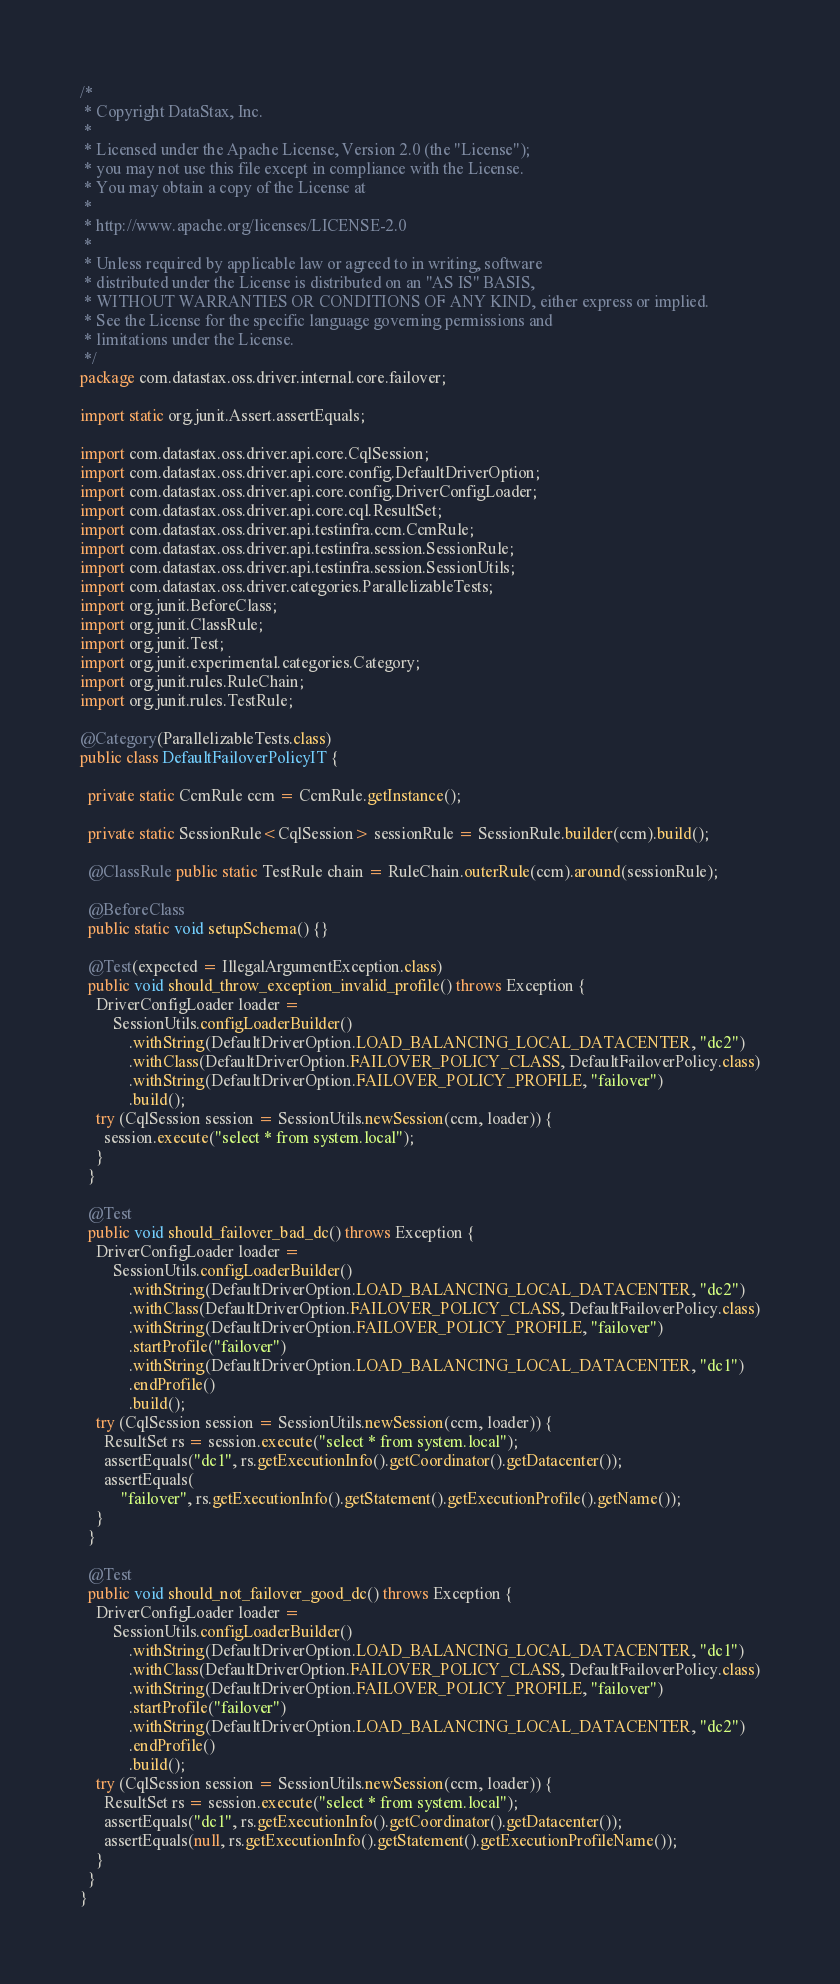Convert code to text. <code><loc_0><loc_0><loc_500><loc_500><_Java_>/*
 * Copyright DataStax, Inc.
 *
 * Licensed under the Apache License, Version 2.0 (the "License");
 * you may not use this file except in compliance with the License.
 * You may obtain a copy of the License at
 *
 * http://www.apache.org/licenses/LICENSE-2.0
 *
 * Unless required by applicable law or agreed to in writing, software
 * distributed under the License is distributed on an "AS IS" BASIS,
 * WITHOUT WARRANTIES OR CONDITIONS OF ANY KIND, either express or implied.
 * See the License for the specific language governing permissions and
 * limitations under the License.
 */
package com.datastax.oss.driver.internal.core.failover;

import static org.junit.Assert.assertEquals;

import com.datastax.oss.driver.api.core.CqlSession;
import com.datastax.oss.driver.api.core.config.DefaultDriverOption;
import com.datastax.oss.driver.api.core.config.DriverConfigLoader;
import com.datastax.oss.driver.api.core.cql.ResultSet;
import com.datastax.oss.driver.api.testinfra.ccm.CcmRule;
import com.datastax.oss.driver.api.testinfra.session.SessionRule;
import com.datastax.oss.driver.api.testinfra.session.SessionUtils;
import com.datastax.oss.driver.categories.ParallelizableTests;
import org.junit.BeforeClass;
import org.junit.ClassRule;
import org.junit.Test;
import org.junit.experimental.categories.Category;
import org.junit.rules.RuleChain;
import org.junit.rules.TestRule;

@Category(ParallelizableTests.class)
public class DefaultFailoverPolicyIT {

  private static CcmRule ccm = CcmRule.getInstance();

  private static SessionRule<CqlSession> sessionRule = SessionRule.builder(ccm).build();

  @ClassRule public static TestRule chain = RuleChain.outerRule(ccm).around(sessionRule);

  @BeforeClass
  public static void setupSchema() {}

  @Test(expected = IllegalArgumentException.class)
  public void should_throw_exception_invalid_profile() throws Exception {
    DriverConfigLoader loader =
        SessionUtils.configLoaderBuilder()
            .withString(DefaultDriverOption.LOAD_BALANCING_LOCAL_DATACENTER, "dc2")
            .withClass(DefaultDriverOption.FAILOVER_POLICY_CLASS, DefaultFailoverPolicy.class)
            .withString(DefaultDriverOption.FAILOVER_POLICY_PROFILE, "failover")
            .build();
    try (CqlSession session = SessionUtils.newSession(ccm, loader)) {
      session.execute("select * from system.local");
    }
  }

  @Test
  public void should_failover_bad_dc() throws Exception {
    DriverConfigLoader loader =
        SessionUtils.configLoaderBuilder()
            .withString(DefaultDriverOption.LOAD_BALANCING_LOCAL_DATACENTER, "dc2")
            .withClass(DefaultDriverOption.FAILOVER_POLICY_CLASS, DefaultFailoverPolicy.class)
            .withString(DefaultDriverOption.FAILOVER_POLICY_PROFILE, "failover")
            .startProfile("failover")
            .withString(DefaultDriverOption.LOAD_BALANCING_LOCAL_DATACENTER, "dc1")
            .endProfile()
            .build();
    try (CqlSession session = SessionUtils.newSession(ccm, loader)) {
      ResultSet rs = session.execute("select * from system.local");
      assertEquals("dc1", rs.getExecutionInfo().getCoordinator().getDatacenter());
      assertEquals(
          "failover", rs.getExecutionInfo().getStatement().getExecutionProfile().getName());
    }
  }

  @Test
  public void should_not_failover_good_dc() throws Exception {
    DriverConfigLoader loader =
        SessionUtils.configLoaderBuilder()
            .withString(DefaultDriverOption.LOAD_BALANCING_LOCAL_DATACENTER, "dc1")
            .withClass(DefaultDriverOption.FAILOVER_POLICY_CLASS, DefaultFailoverPolicy.class)
            .withString(DefaultDriverOption.FAILOVER_POLICY_PROFILE, "failover")
            .startProfile("failover")
            .withString(DefaultDriverOption.LOAD_BALANCING_LOCAL_DATACENTER, "dc2")
            .endProfile()
            .build();
    try (CqlSession session = SessionUtils.newSession(ccm, loader)) {
      ResultSet rs = session.execute("select * from system.local");
      assertEquals("dc1", rs.getExecutionInfo().getCoordinator().getDatacenter());
      assertEquals(null, rs.getExecutionInfo().getStatement().getExecutionProfileName());
    }
  }
}
</code> 